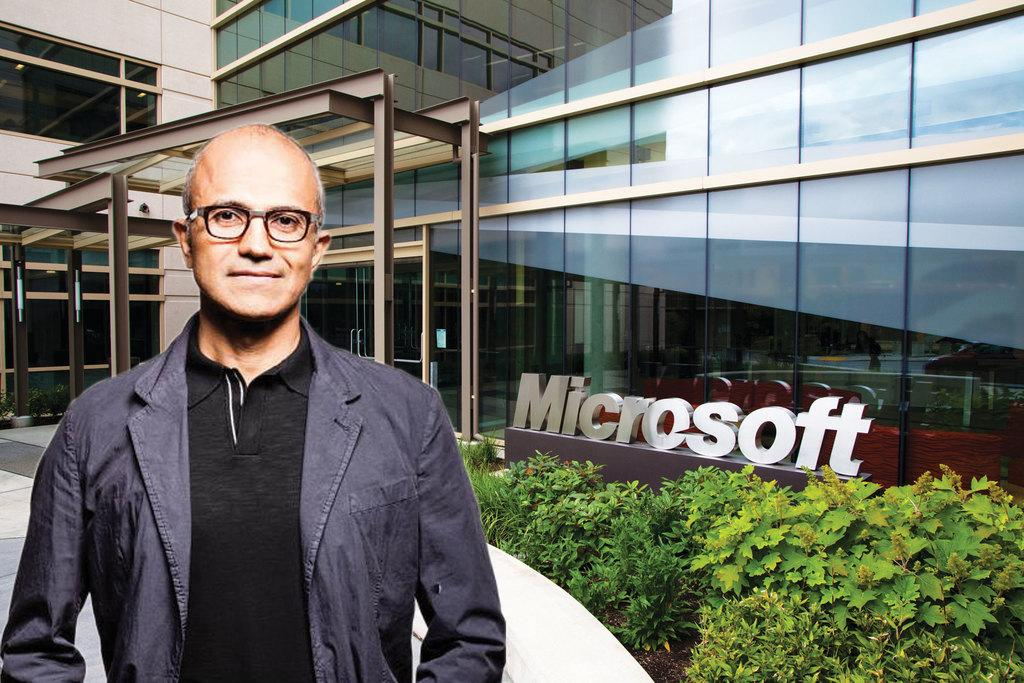What is the main subject of the image? There is a person in the image. Can you describe the person's clothing? The person is wearing a black T-shirt and a jacket. What can be seen in the background of the image? There are planets visible in the image, as well as a building. What is the name of the building in the image? The building has a name associated with it. What is at the bottom of the image? There is a path at the bottom of the image. What type of shop can be seen in the image? There is no shop present in the image. 